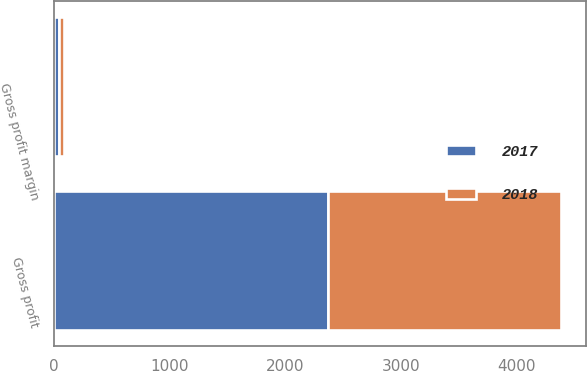<chart> <loc_0><loc_0><loc_500><loc_500><stacked_bar_chart><ecel><fcel>Gross profit<fcel>Gross profit margin<nl><fcel>2017<fcel>2371.6<fcel>43.8<nl><fcel>2018<fcel>2010.2<fcel>41.6<nl></chart> 